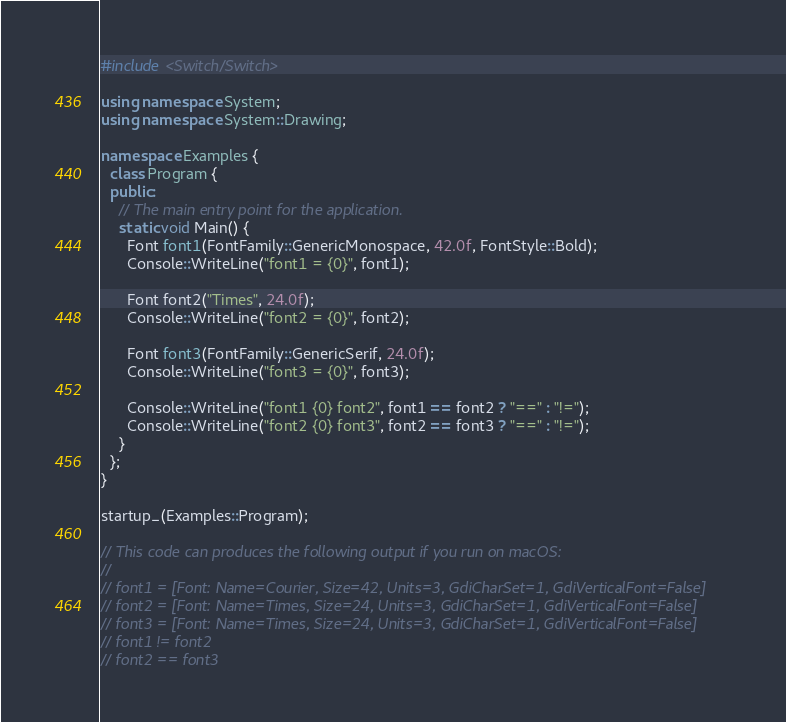Convert code to text. <code><loc_0><loc_0><loc_500><loc_500><_C++_>#include <Switch/Switch>

using namespace System;
using namespace System::Drawing;

namespace Examples {
  class Program {
  public:
    // The main entry point for the application.
    static void Main() {
      Font font1(FontFamily::GenericMonospace, 42.0f, FontStyle::Bold);
      Console::WriteLine("font1 = {0}", font1);

      Font font2("Times", 24.0f);
      Console::WriteLine("font2 = {0}", font2);

      Font font3(FontFamily::GenericSerif, 24.0f);
      Console::WriteLine("font3 = {0}", font3);

      Console::WriteLine("font1 {0} font2", font1 == font2 ? "==" : "!=");
      Console::WriteLine("font2 {0} font3", font2 == font3 ? "==" : "!=");
    }
  };
}

startup_(Examples::Program);

// This code can produces the following output if you run on macOS:
//
// font1 = [Font: Name=Courier, Size=42, Units=3, GdiCharSet=1, GdiVerticalFont=False]
// font2 = [Font: Name=Times, Size=24, Units=3, GdiCharSet=1, GdiVerticalFont=False]
// font3 = [Font: Name=Times, Size=24, Units=3, GdiCharSet=1, GdiVerticalFont=False]
// font1 != font2
// font2 == font3
</code> 